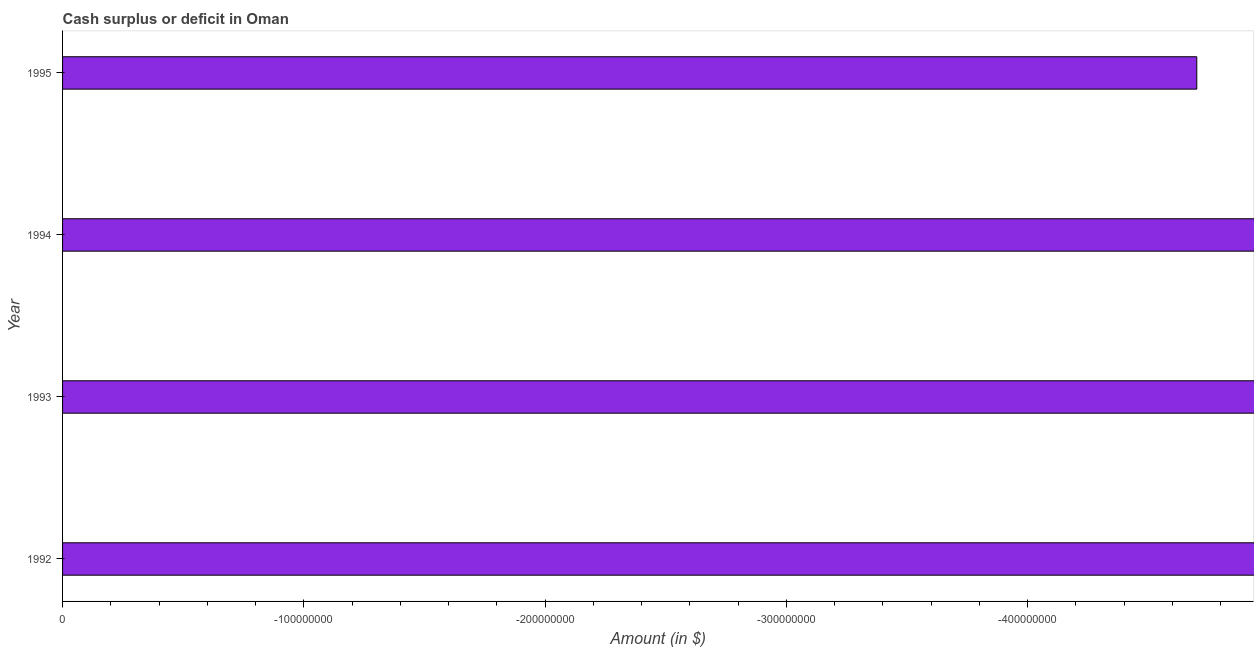Does the graph contain any zero values?
Give a very brief answer. Yes. What is the title of the graph?
Offer a terse response. Cash surplus or deficit in Oman. What is the label or title of the X-axis?
Offer a terse response. Amount (in $). What is the label or title of the Y-axis?
Offer a terse response. Year. What is the sum of the cash surplus or deficit?
Give a very brief answer. 0. What is the average cash surplus or deficit per year?
Give a very brief answer. 0. What is the median cash surplus or deficit?
Keep it short and to the point. 0. In how many years, is the cash surplus or deficit greater than -100000000 $?
Your answer should be compact. 0. In how many years, is the cash surplus or deficit greater than the average cash surplus or deficit taken over all years?
Your response must be concise. 0. How many bars are there?
Make the answer very short. 0. Are all the bars in the graph horizontal?
Your response must be concise. Yes. What is the difference between two consecutive major ticks on the X-axis?
Your response must be concise. 1.00e+08. Are the values on the major ticks of X-axis written in scientific E-notation?
Make the answer very short. No. What is the Amount (in $) of 1992?
Offer a very short reply. 0. What is the Amount (in $) of 1993?
Ensure brevity in your answer.  0. What is the Amount (in $) of 1995?
Provide a short and direct response. 0. 